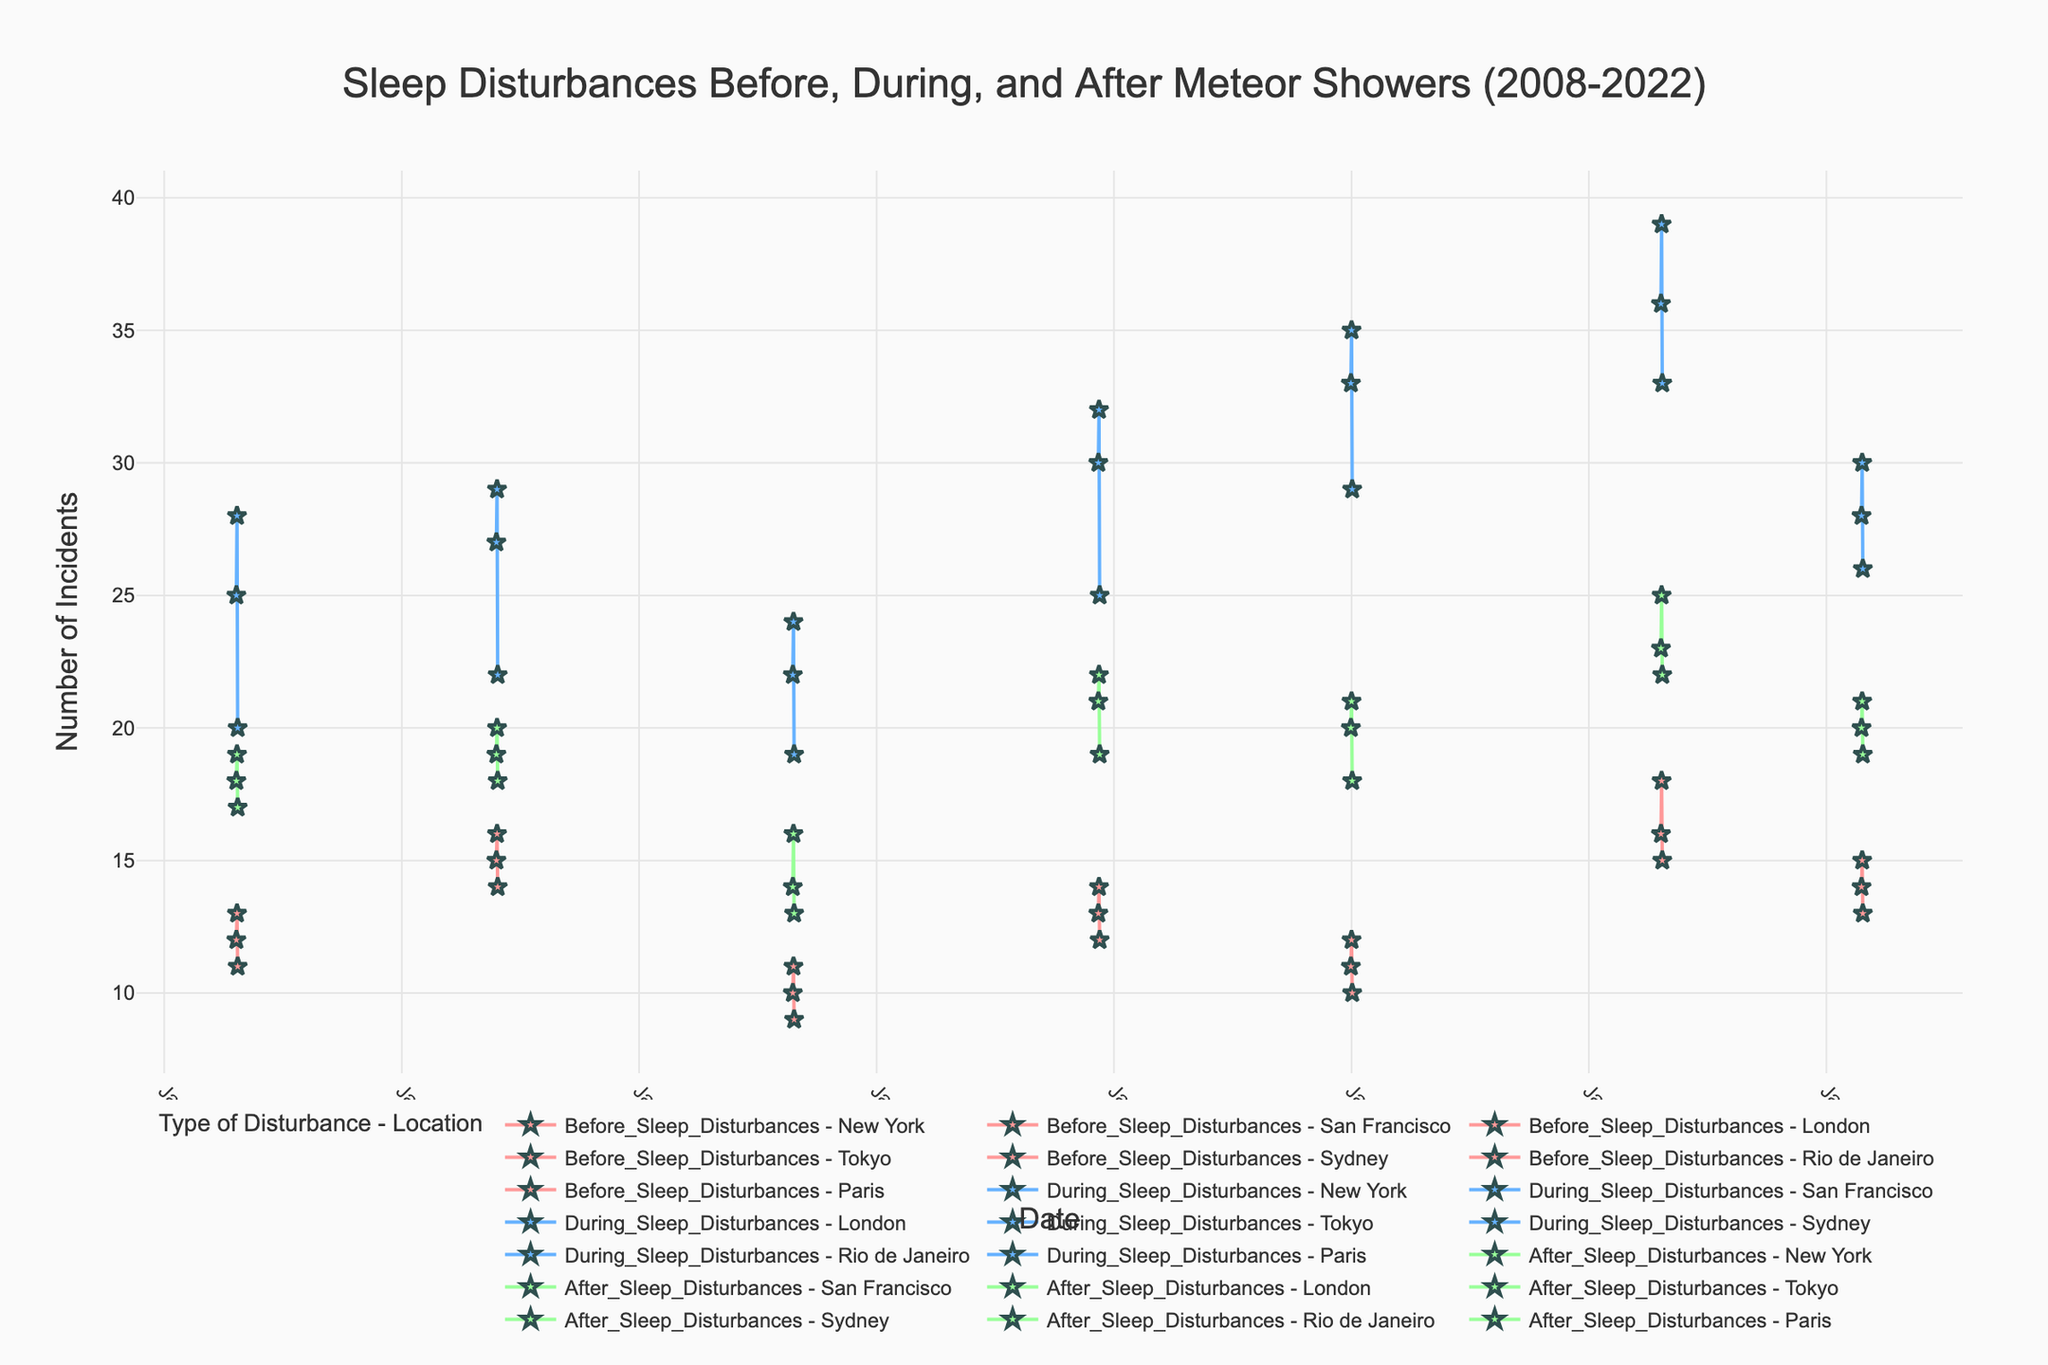What is the title of the figure? The title is at the top of the figure, stating the focus of the plot.
Answer: "Sleep Disturbances Before, During, and After Meteor Showers (2008-2022)" Over which time period is the data collected in the plot? The x-axis indicates dates ranging from the earliest to the latest data points, showing the time range of the collected data.
Answer: 2008 to 2022 How does the number of sleep disturbances in New York change during the meteor showers? Refer to the lines marked with "During_Sleep_Disturbances - New York" to observe the pattern and change in incidents reported. The numbers jump significantly compared to before and after the meteor showers.
Answer: Increases Which location reported the highest number of sleep disturbances during the meteor showers? Compare all the location lines for "During_Sleep_Disturbances" and identify the peak value.
Answer: Rio de Janeiro What is the difference in the number of sleep disturbances before and after meteor showers in Tokyo in 2015? Locate the data points for Tokyo in 2015, subtract the number of incidents after the meteor shower from those before.
Answer: 2 (13 before - 21 after) Which event location has the smallest increase in sleep disturbances during the meteor showers compared to before? Calculate the difference between before and during for each location and identify the smallest increment.
Answer: London What trend can you observe in the number of sleep disturbances during meteor showers over the years? Observe the lines for "During_Sleep_Disturbances" across all locations and years to identify any trend. It generally shows a rising trend.
Answer: Increasing On what date was the peak number of sleep disturbances reported in Sydney? Sydney's peak can be found by looking at the dates and the corresponding highest point on "During_Sleep_Disturbances - Sydney".
Answer: January 1, 2018 Compare the number of incidents during meteor showers in London (2013) with San Francisco (2010). Which city had more incidents? Look at the values for "During_Sleep_Disturbances" for the specified dates and compare the two.
Answer: San Francisco What is the average number of sleep disturbances reported in Paris during the meteor showers in 2022? Sum the values for Paris during the listed dates in 2022, then divide by the number of data points to get the average.
Answer: 28 (Sum is 84 and there are 3 data points) 